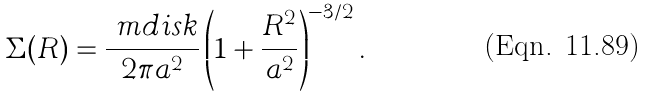Convert formula to latex. <formula><loc_0><loc_0><loc_500><loc_500>\Sigma ( R ) = \frac { \ m d i s k } { 2 \pi a ^ { 2 } } \left ( 1 + \frac { R ^ { 2 } } { a ^ { 2 } } \right ) ^ { - 3 / 2 } .</formula> 